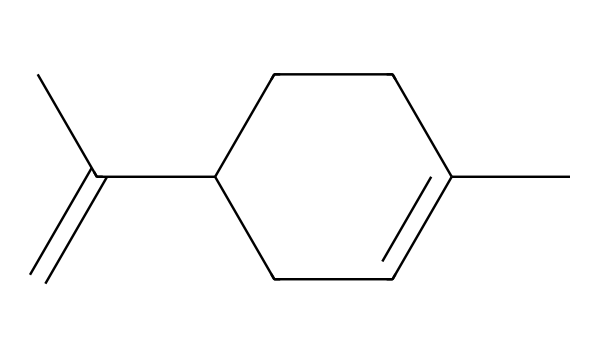What is the molecular formula of this compound? To determine the molecular formula, count the number of carbon (C), hydrogen (H), and other atoms in the SMILES string. The molecule contains 10 carbons and 16 hydrogens, providing the formula C10H16.
Answer: C10H16 How many carbon atoms are present? By analyzing the SMILES representation, there are 10 carbon atoms denoted by the letter 'C'.
Answer: 10 What functional group is absent in this molecule? Upon examining the structure, we see that there are no oxygen (O) or nitrogen (N) atoms indicating that functional groups like alcohols (–OH) or amines (–NH2) are absent.
Answer: oxygen, nitrogen Which type of compound does this belong to? This molecule is a hydrocarbon as it consists only of carbon and hydrogen without heteroatoms like oxygen or nitrogen. Hydrocarbons are typically classified into alkanes, alkenes, or alkynes, and the presence of a double bond (C=C) indicates that it is an alkene.
Answer: alkene How many double bonds does this molecule have? By carefully counting the instances of double bonds in the structure, there is one double bond present between two carbon atoms.
Answer: 1 What is the saturated nature of this compound? By examining the structure, it is evident that due to the presence of a double bond, the compound does not achieve full saturation, marking it as unsaturated.
Answer: unsaturated 